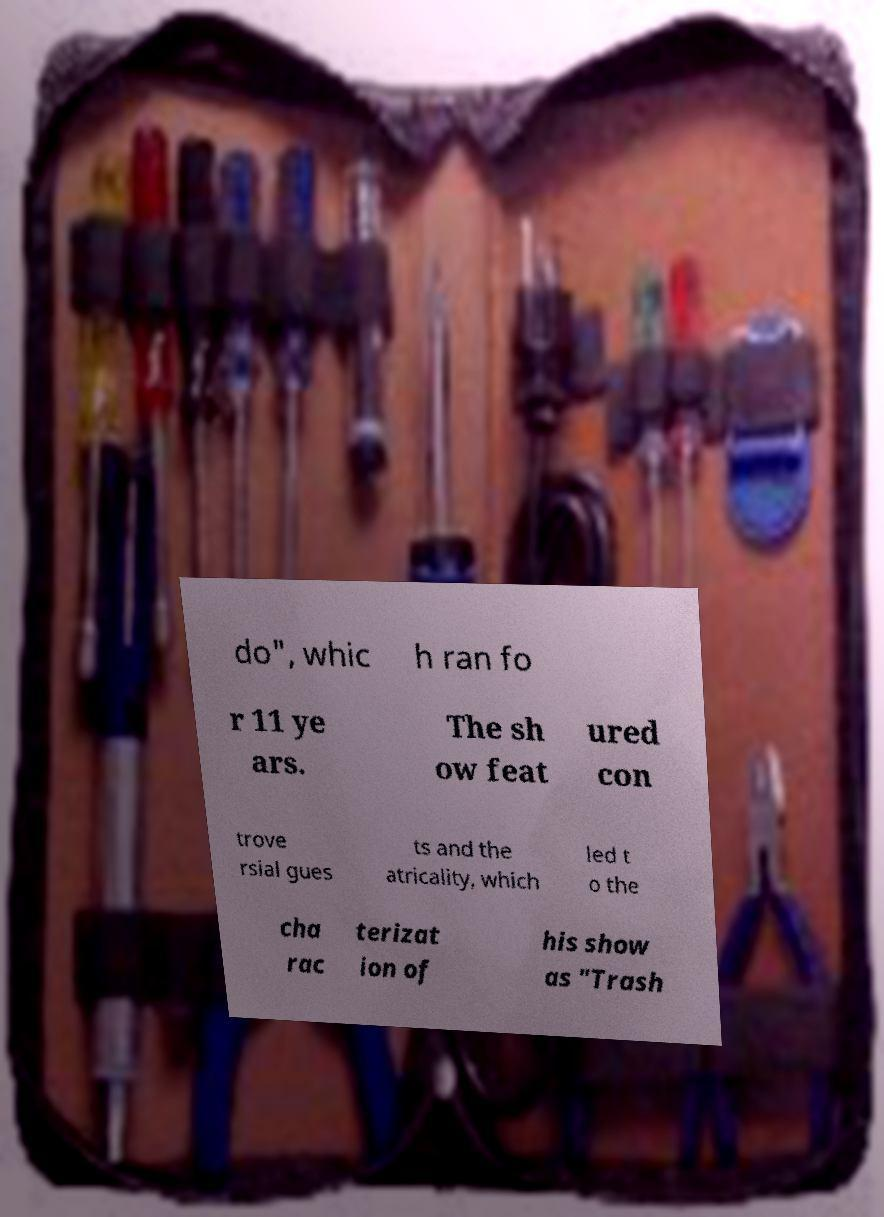Please identify and transcribe the text found in this image. do", whic h ran fo r 11 ye ars. The sh ow feat ured con trove rsial gues ts and the atricality, which led t o the cha rac terizat ion of his show as "Trash 